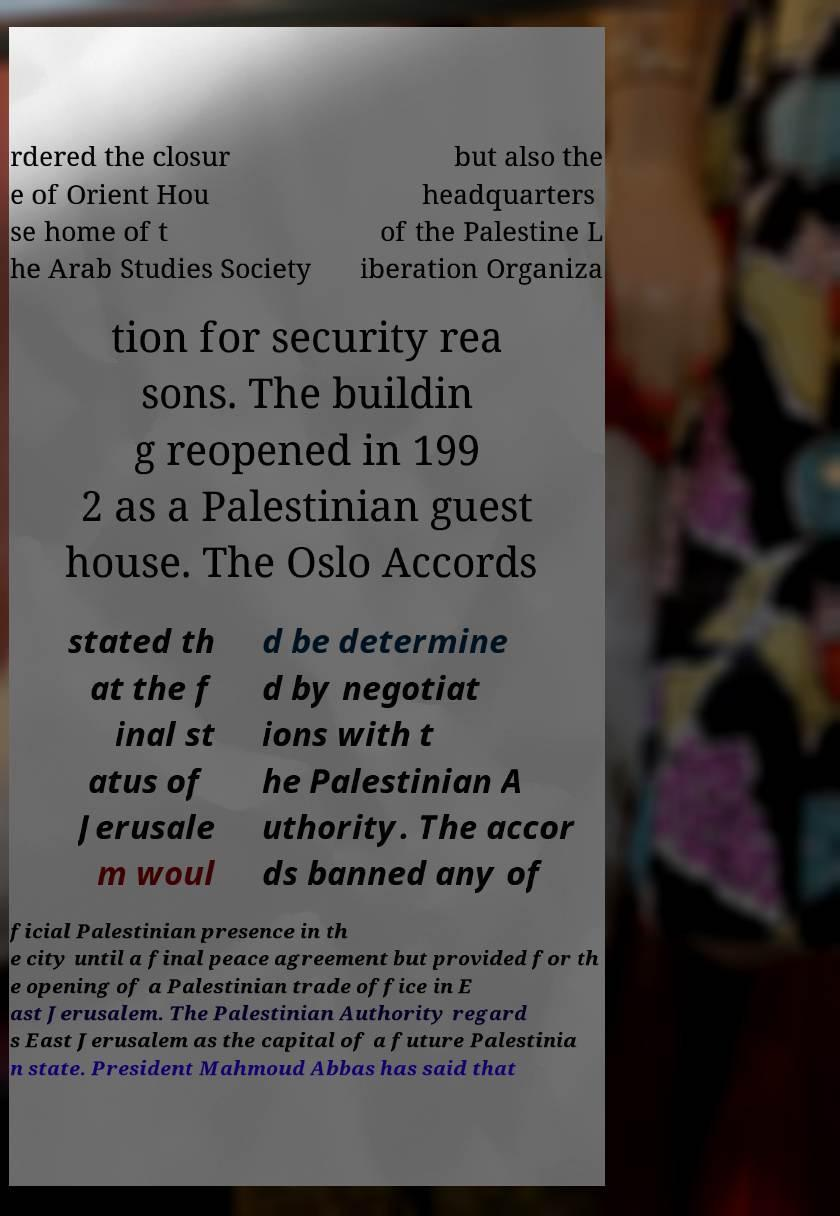I need the written content from this picture converted into text. Can you do that? rdered the closur e of Orient Hou se home of t he Arab Studies Society but also the headquarters of the Palestine L iberation Organiza tion for security rea sons. The buildin g reopened in 199 2 as a Palestinian guest house. The Oslo Accords stated th at the f inal st atus of Jerusale m woul d be determine d by negotiat ions with t he Palestinian A uthority. The accor ds banned any of ficial Palestinian presence in th e city until a final peace agreement but provided for th e opening of a Palestinian trade office in E ast Jerusalem. The Palestinian Authority regard s East Jerusalem as the capital of a future Palestinia n state. President Mahmoud Abbas has said that 